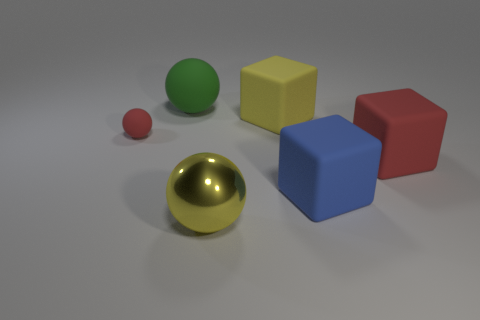What material is the blue thing that is the same size as the green object?
Offer a very short reply. Rubber. How many large objects are there?
Provide a short and direct response. 5. There is a rubber thing that is on the left side of the green matte object; how big is it?
Your answer should be very brief. Small. Are there the same number of large green spheres that are on the left side of the large matte ball and small green rubber cylinders?
Your answer should be very brief. Yes. Is there a red rubber thing that has the same shape as the blue object?
Make the answer very short. Yes. What is the shape of the large thing that is on the left side of the big yellow matte cube and behind the yellow ball?
Ensure brevity in your answer.  Sphere. Do the yellow ball and the cube that is to the right of the big blue matte thing have the same material?
Ensure brevity in your answer.  No. There is a big green sphere; are there any big things right of it?
Make the answer very short. Yes. How many objects are small cyan matte cylinders or red matte objects on the left side of the big green rubber thing?
Your answer should be compact. 1. There is a big rubber thing that is on the left side of the large ball in front of the yellow rubber object; what is its color?
Your response must be concise. Green. 